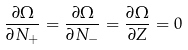<formula> <loc_0><loc_0><loc_500><loc_500>\frac { \partial \Omega } { \partial N _ { + } } = \frac { \partial \Omega } { \partial N _ { - } } = \frac { \partial \Omega } { \partial Z } = 0</formula> 